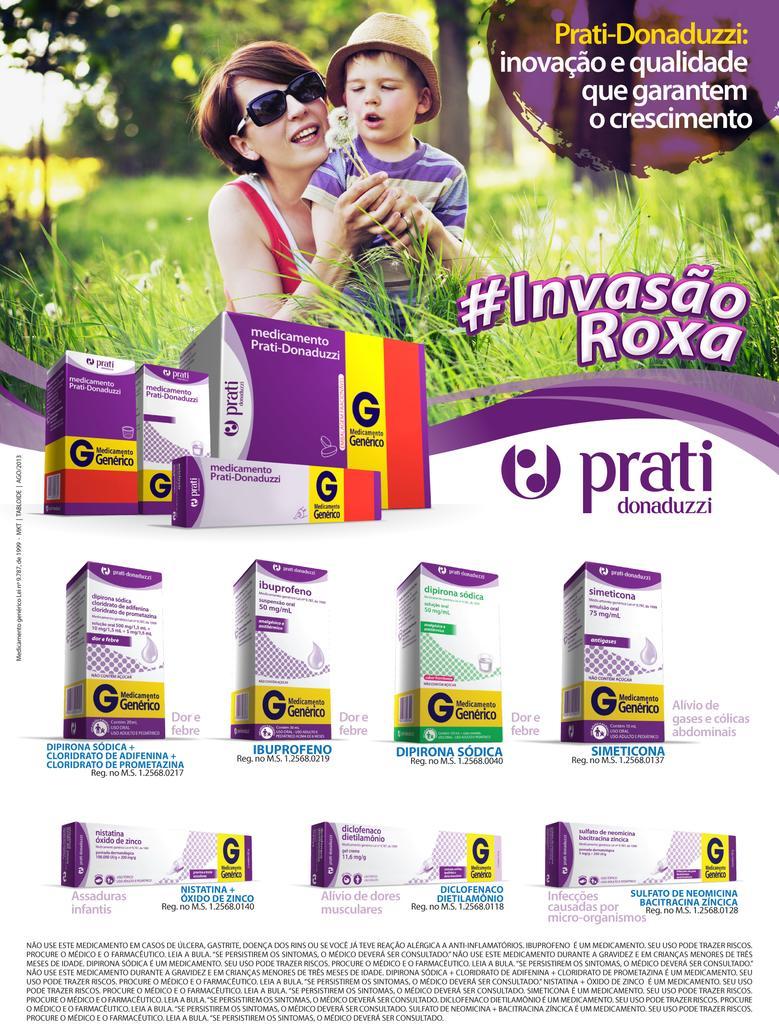Describe this image in one or two sentences. This image looks like a poster. It is an advertisement. There are two persons at the top. One is a woman, another one is a child. There is grass in the middle. There is something written on this image. 